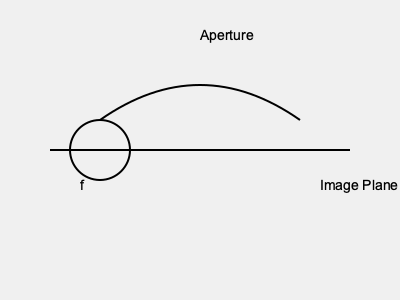As an expert in exposing paparazzi techniques, analyze the diagram of a telephoto lens commonly used by paparazzi. If the focal length (f) is 400mm and the lens produces an f-number of f/5.6, calculate the diameter of the aperture. How might this information be useful in identifying and countering paparazzi equipment? To solve this problem, we need to understand the relationship between focal length, f-number, and aperture diameter. Let's break it down step-by-step:

1) The f-number is defined as the ratio of the focal length to the diameter of the aperture. Mathematically, this is expressed as:

   $f\text{-number} = \frac{\text{focal length}}{\text{aperture diameter}}$

2) We are given:
   - Focal length (f) = 400mm
   - f-number = 5.6

3) Let's call the aperture diameter D. We can set up the equation:

   $5.6 = \frac{400mm}{D}$

4) To solve for D, we multiply both sides by D and then divide by 5.6:

   $D = \frac{400mm}{5.6}$

5) Calculating this:

   $D \approx 71.43mm$

This information can be useful in identifying and countering paparazzi equipment in several ways:

a) Lens recognition: Knowing the focal length and aperture size can help identify specific lens models used by paparazzi.

b) Shooting conditions: A large aperture (small f-number) allows for shooting in low light conditions, which is often favored by paparazzi for discreet photography.

c) Image compression: Long focal lengths compress perspective, a technique often used by paparazzi to make distant subjects appear closer.

d) Counter-strategies: Understanding these lens characteristics can help develop methods to obstruct or confuse such equipment, like using light-based countermeasures that exploit the large aperture.
Answer: Aperture diameter ≈ 71.43mm 